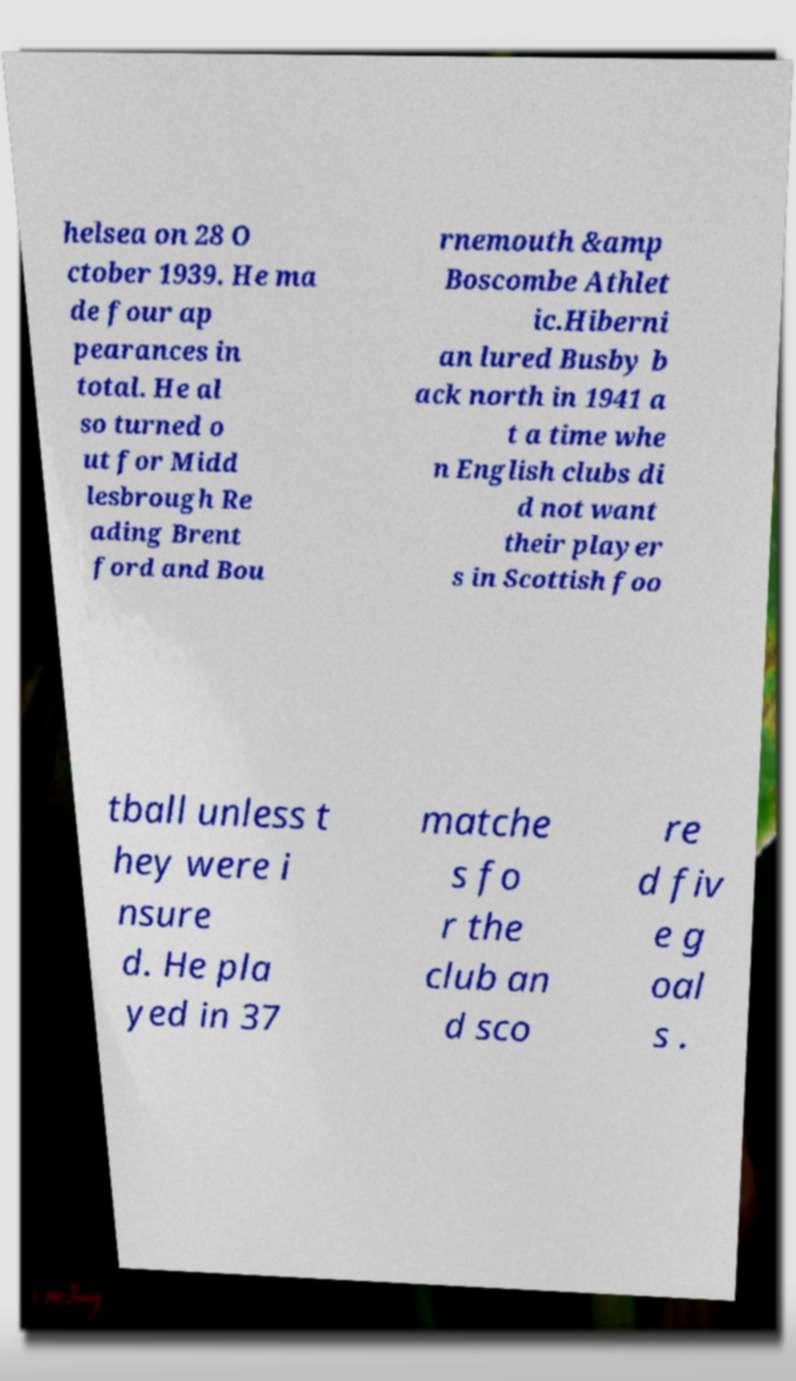There's text embedded in this image that I need extracted. Can you transcribe it verbatim? helsea on 28 O ctober 1939. He ma de four ap pearances in total. He al so turned o ut for Midd lesbrough Re ading Brent ford and Bou rnemouth &amp Boscombe Athlet ic.Hiberni an lured Busby b ack north in 1941 a t a time whe n English clubs di d not want their player s in Scottish foo tball unless t hey were i nsure d. He pla yed in 37 matche s fo r the club an d sco re d fiv e g oal s . 